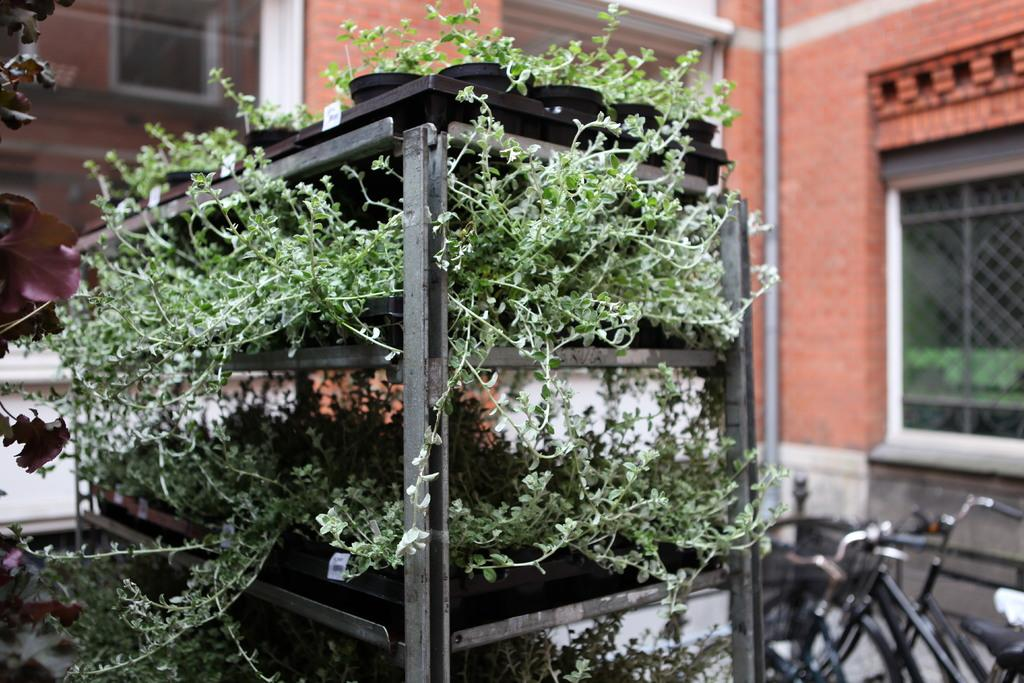What type of plants are in the image? The plants are potted in trays in the image. Where are the plants located in the image? The plants are placed in a cupboard. What can be seen in the background of the image? There are buildings, windows, pipelines, and bicycles in the background of the image. What type of chalk is being used to draw on the bicycles in the image? There is no chalk or drawing on the bicycles in the image. What type of polish is being applied to the plants in the image? There is no polish being applied to the plants in the image. 